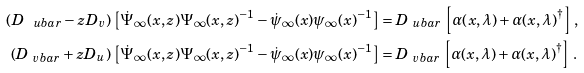Convert formula to latex. <formula><loc_0><loc_0><loc_500><loc_500>\left ( D _ { \ u b a r } - z D _ { v } \right ) \, \left [ \dot { \Psi } _ { \infty } ( x , z ) \Psi _ { \infty } ( x , z ) ^ { - 1 } - \dot { \psi } _ { \infty } ( x ) \psi _ { \infty } ( x ) ^ { - 1 } \right ] & = D _ { \ u b a r } \, \left [ \alpha ( x , \lambda ) + \alpha ( x , \lambda ) ^ { \dagger } \right ] \, , \\ \left ( D _ { \ v b a r } + z D _ { u } \right ) \, \left [ \dot { \Psi } _ { \infty } ( x , z ) \Psi _ { \infty } ( x , z ) ^ { - 1 } - \dot { \psi } _ { \infty } ( x ) \psi _ { \infty } ( x ) ^ { - 1 } \right ] & = D _ { \ v b a r } \, \left [ \alpha ( x , \lambda ) + \alpha ( x , \lambda ) ^ { \dagger } \right ] \, .</formula> 